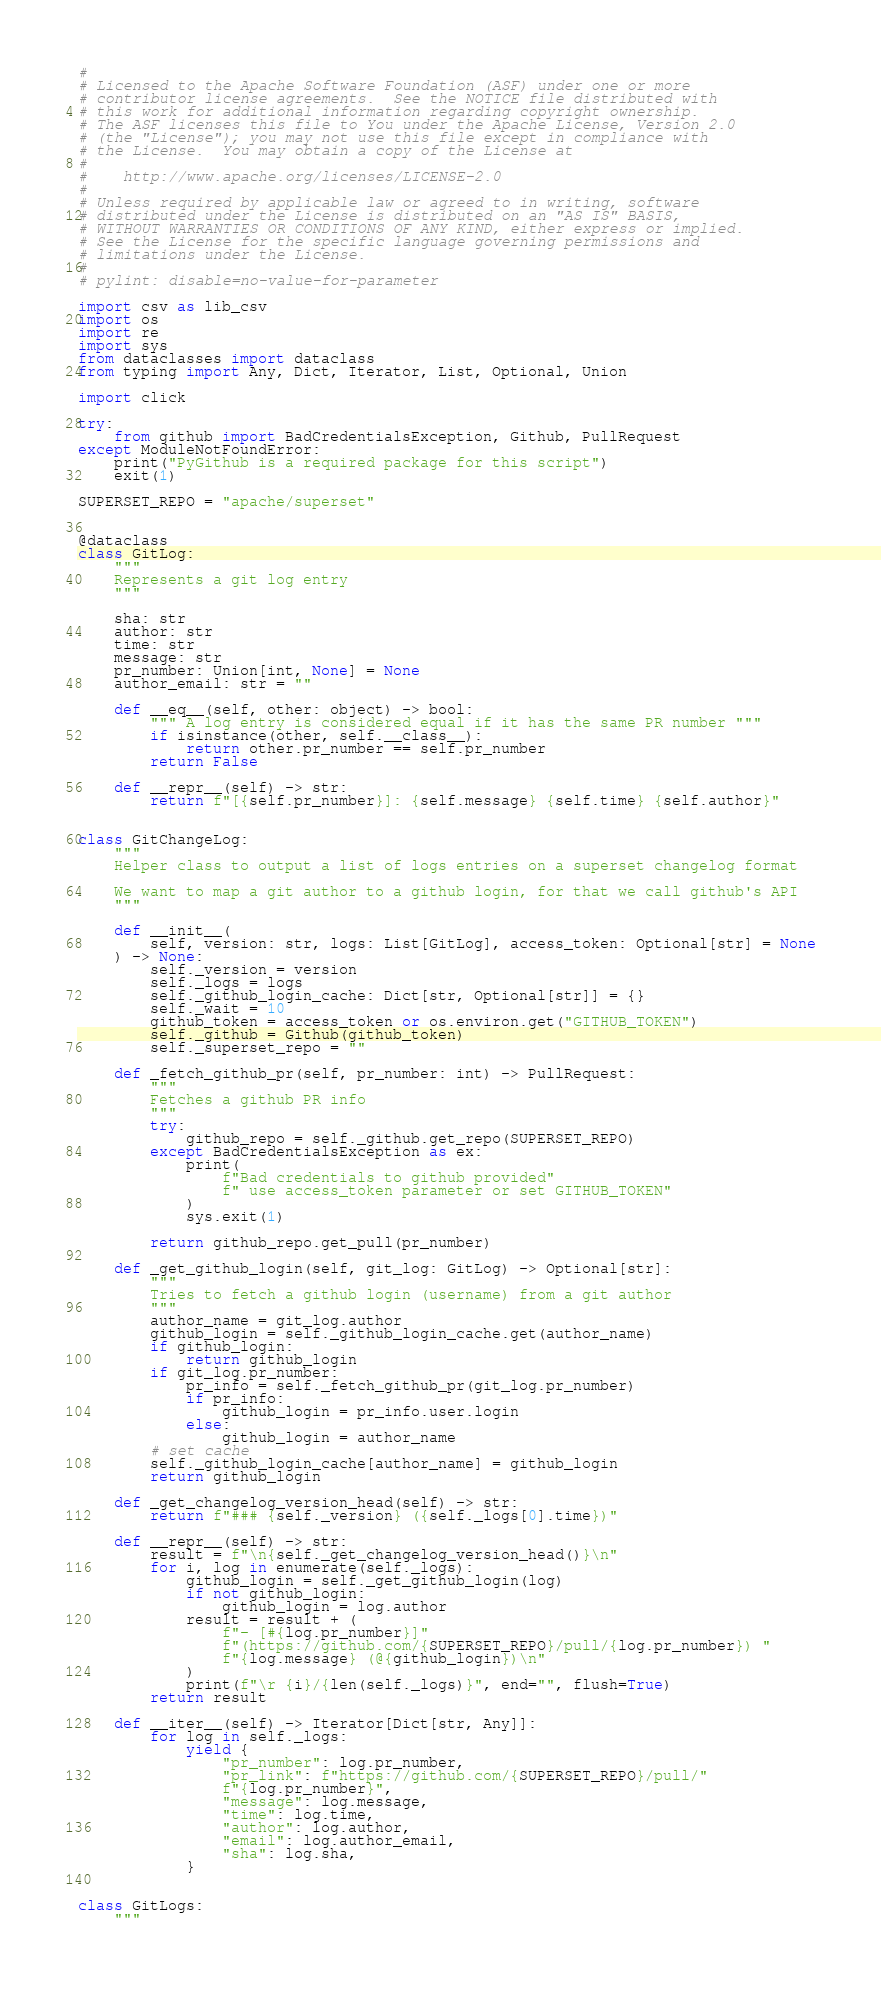Convert code to text. <code><loc_0><loc_0><loc_500><loc_500><_Python_>#
# Licensed to the Apache Software Foundation (ASF) under one or more
# contributor license agreements.  See the NOTICE file distributed with
# this work for additional information regarding copyright ownership.
# The ASF licenses this file to You under the Apache License, Version 2.0
# (the "License"); you may not use this file except in compliance with
# the License.  You may obtain a copy of the License at
#
#    http://www.apache.org/licenses/LICENSE-2.0
#
# Unless required by applicable law or agreed to in writing, software
# distributed under the License is distributed on an "AS IS" BASIS,
# WITHOUT WARRANTIES OR CONDITIONS OF ANY KIND, either express or implied.
# See the License for the specific language governing permissions and
# limitations under the License.
#
# pylint: disable=no-value-for-parameter

import csv as lib_csv
import os
import re
import sys
from dataclasses import dataclass
from typing import Any, Dict, Iterator, List, Optional, Union

import click

try:
    from github import BadCredentialsException, Github, PullRequest
except ModuleNotFoundError:
    print("PyGithub is a required package for this script")
    exit(1)

SUPERSET_REPO = "apache/superset"


@dataclass
class GitLog:
    """
    Represents a git log entry
    """

    sha: str
    author: str
    time: str
    message: str
    pr_number: Union[int, None] = None
    author_email: str = ""

    def __eq__(self, other: object) -> bool:
        """ A log entry is considered equal if it has the same PR number """
        if isinstance(other, self.__class__):
            return other.pr_number == self.pr_number
        return False

    def __repr__(self) -> str:
        return f"[{self.pr_number}]: {self.message} {self.time} {self.author}"


class GitChangeLog:
    """
    Helper class to output a list of logs entries on a superset changelog format

    We want to map a git author to a github login, for that we call github's API
    """

    def __init__(
        self, version: str, logs: List[GitLog], access_token: Optional[str] = None
    ) -> None:
        self._version = version
        self._logs = logs
        self._github_login_cache: Dict[str, Optional[str]] = {}
        self._wait = 10
        github_token = access_token or os.environ.get("GITHUB_TOKEN")
        self._github = Github(github_token)
        self._superset_repo = ""

    def _fetch_github_pr(self, pr_number: int) -> PullRequest:
        """
        Fetches a github PR info
        """
        try:
            github_repo = self._github.get_repo(SUPERSET_REPO)
        except BadCredentialsException as ex:
            print(
                f"Bad credentials to github provided"
                f" use access_token parameter or set GITHUB_TOKEN"
            )
            sys.exit(1)

        return github_repo.get_pull(pr_number)

    def _get_github_login(self, git_log: GitLog) -> Optional[str]:
        """
        Tries to fetch a github login (username) from a git author
        """
        author_name = git_log.author
        github_login = self._github_login_cache.get(author_name)
        if github_login:
            return github_login
        if git_log.pr_number:
            pr_info = self._fetch_github_pr(git_log.pr_number)
            if pr_info:
                github_login = pr_info.user.login
            else:
                github_login = author_name
        # set cache
        self._github_login_cache[author_name] = github_login
        return github_login

    def _get_changelog_version_head(self) -> str:
        return f"### {self._version} ({self._logs[0].time})"

    def __repr__(self) -> str:
        result = f"\n{self._get_changelog_version_head()}\n"
        for i, log in enumerate(self._logs):
            github_login = self._get_github_login(log)
            if not github_login:
                github_login = log.author
            result = result + (
                f"- [#{log.pr_number}]"
                f"(https://github.com/{SUPERSET_REPO}/pull/{log.pr_number}) "
                f"{log.message} (@{github_login})\n"
            )
            print(f"\r {i}/{len(self._logs)}", end="", flush=True)
        return result

    def __iter__(self) -> Iterator[Dict[str, Any]]:
        for log in self._logs:
            yield {
                "pr_number": log.pr_number,
                "pr_link": f"https://github.com/{SUPERSET_REPO}/pull/"
                f"{log.pr_number}",
                "message": log.message,
                "time": log.time,
                "author": log.author,
                "email": log.author_email,
                "sha": log.sha,
            }


class GitLogs:
    """</code> 